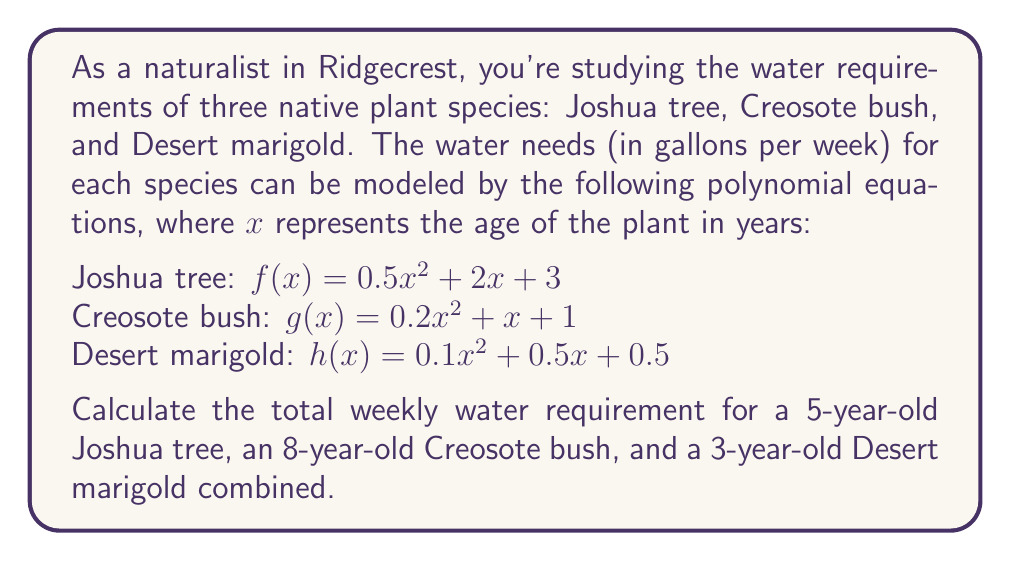Provide a solution to this math problem. Let's calculate the water requirement for each plant separately and then sum them up:

1. For the 5-year-old Joshua tree:
   $f(5) = 0.5(5^2) + 2(5) + 3$
   $= 0.5(25) + 10 + 3$
   $= 12.5 + 10 + 3$
   $= 25.5$ gallons per week

2. For the 8-year-old Creosote bush:
   $g(8) = 0.2(8^2) + 1(8) + 1$
   $= 0.2(64) + 8 + 1$
   $= 12.8 + 8 + 1$
   $= 21.8$ gallons per week

3. For the 3-year-old Desert marigold:
   $h(3) = 0.1(3^2) + 0.5(3) + 0.5$
   $= 0.1(9) + 1.5 + 0.5$
   $= 0.9 + 1.5 + 0.5$
   $= 2.9$ gallons per week

Now, we sum up the water requirements for all three plants:
$25.5 + 21.8 + 2.9 = 50.2$ gallons per week
Answer: 50.2 gallons per week 